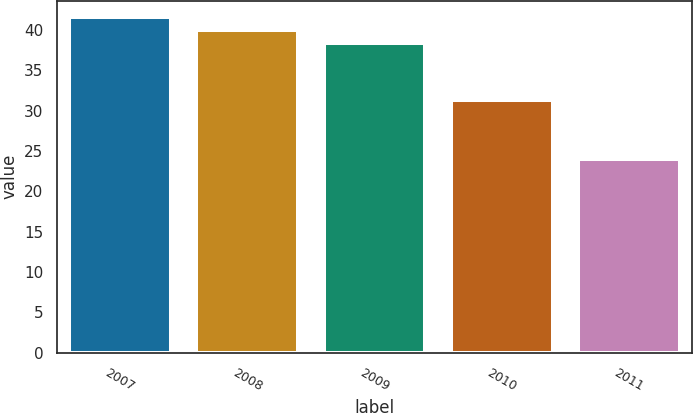Convert chart to OTSL. <chart><loc_0><loc_0><loc_500><loc_500><bar_chart><fcel>2007<fcel>2008<fcel>2009<fcel>2010<fcel>2011<nl><fcel>41.54<fcel>39.97<fcel>38.4<fcel>31.3<fcel>24<nl></chart> 